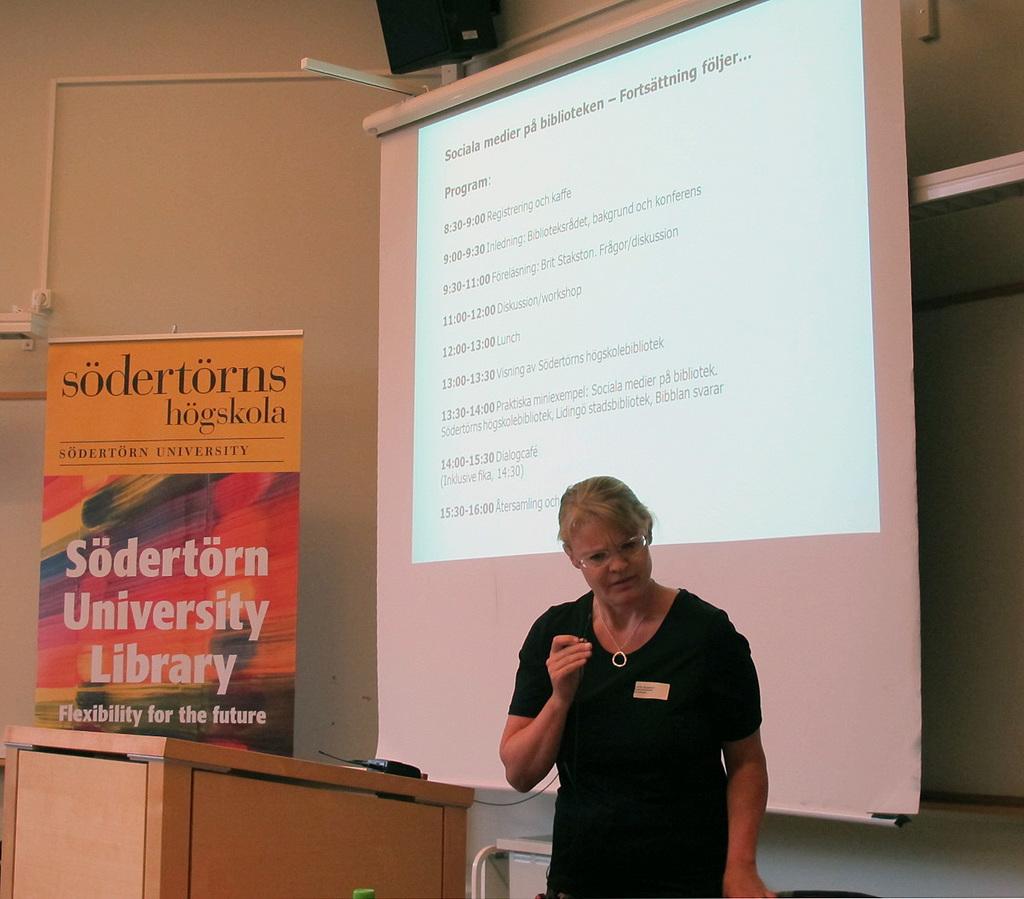What is the catchphrase at the bottom of the book?
Offer a terse response. Flexibility for the future. What school is this from?
Your answer should be very brief. Sodertorn university. 